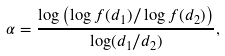<formula> <loc_0><loc_0><loc_500><loc_500>\alpha = \frac { \log \left ( \log f ( d _ { 1 } ) / \log f ( d _ { 2 } ) \right ) } { \log ( d _ { 1 } / d _ { 2 } ) } ,</formula> 